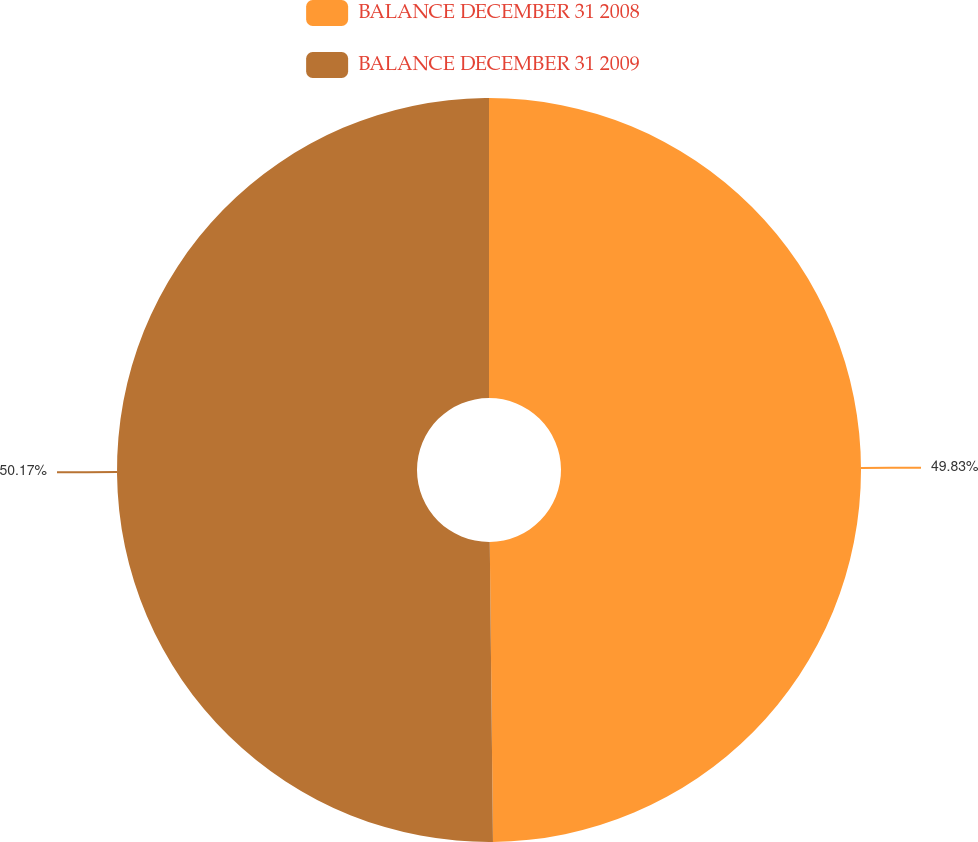Convert chart. <chart><loc_0><loc_0><loc_500><loc_500><pie_chart><fcel>BALANCE DECEMBER 31 2008<fcel>BALANCE DECEMBER 31 2009<nl><fcel>49.83%<fcel>50.17%<nl></chart> 